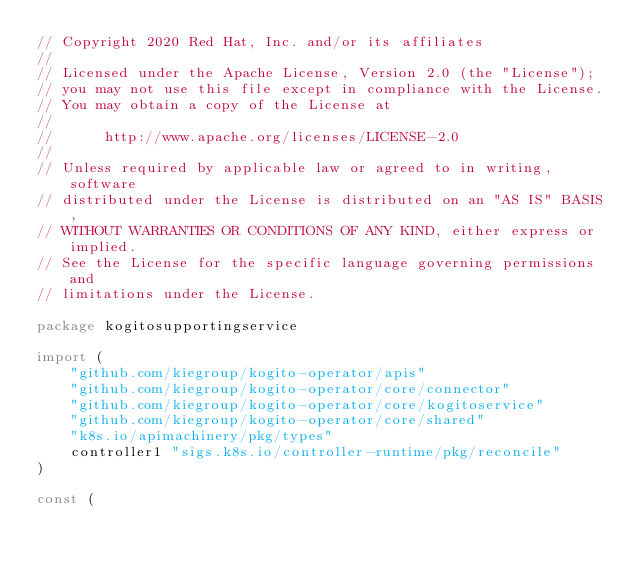Convert code to text. <code><loc_0><loc_0><loc_500><loc_500><_Go_>// Copyright 2020 Red Hat, Inc. and/or its affiliates
//
// Licensed under the Apache License, Version 2.0 (the "License");
// you may not use this file except in compliance with the License.
// You may obtain a copy of the License at
//
//      http://www.apache.org/licenses/LICENSE-2.0
//
// Unless required by applicable law or agreed to in writing, software
// distributed under the License is distributed on an "AS IS" BASIS,
// WITHOUT WARRANTIES OR CONDITIONS OF ANY KIND, either express or implied.
// See the License for the specific language governing permissions and
// limitations under the License.

package kogitosupportingservice

import (
	"github.com/kiegroup/kogito-operator/apis"
	"github.com/kiegroup/kogito-operator/core/connector"
	"github.com/kiegroup/kogito-operator/core/kogitoservice"
	"github.com/kiegroup/kogito-operator/core/shared"
	"k8s.io/apimachinery/pkg/types"
	controller1 "sigs.k8s.io/controller-runtime/pkg/reconcile"
)

const (</code> 